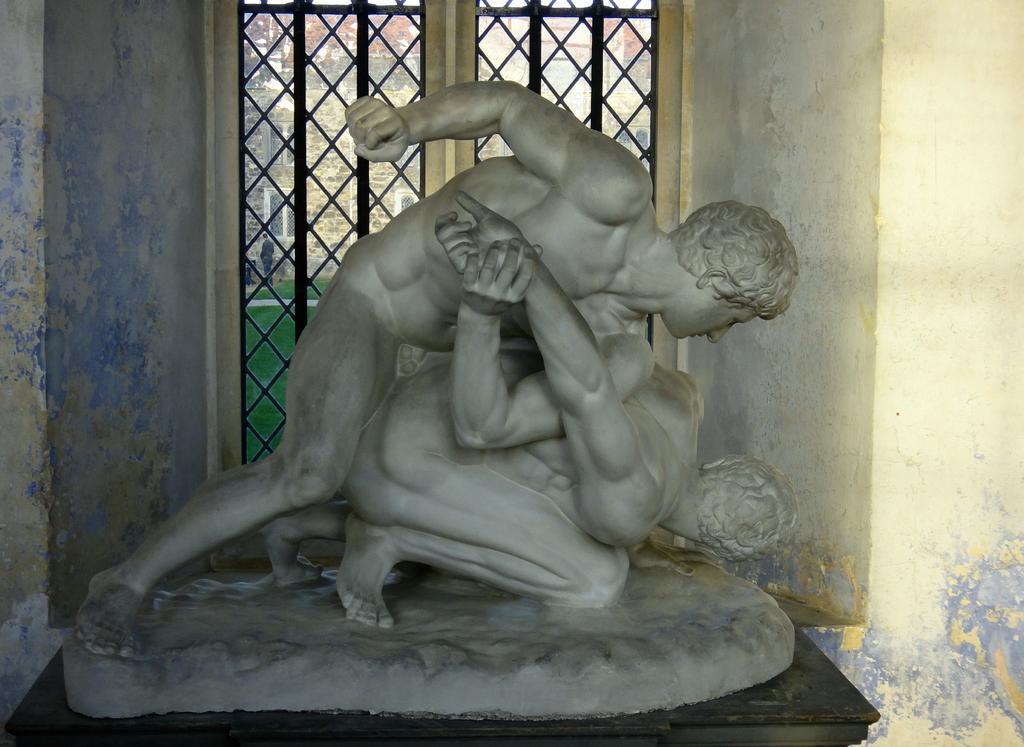In one or two sentences, can you explain what this image depicts? In this image in the front there are statues. In the background there is a window and behind the window there's grass on the ground and there is a building. 